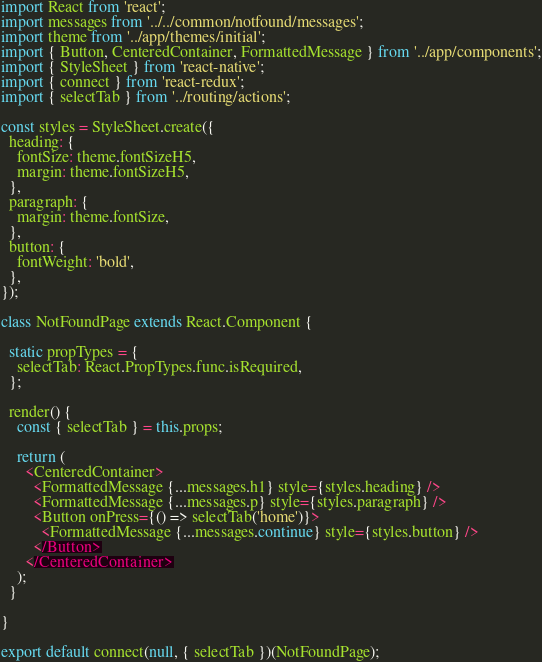Convert code to text. <code><loc_0><loc_0><loc_500><loc_500><_JavaScript_>import React from 'react';
import messages from '../../common/notfound/messages';
import theme from '../app/themes/initial';
import { Button, CenteredContainer, FormattedMessage } from '../app/components';
import { StyleSheet } from 'react-native';
import { connect } from 'react-redux';
import { selectTab } from '../routing/actions';

const styles = StyleSheet.create({
  heading: {
    fontSize: theme.fontSizeH5,
    margin: theme.fontSizeH5,
  },
  paragraph: {
    margin: theme.fontSize,
  },
  button: {
    fontWeight: 'bold',
  },
});

class NotFoundPage extends React.Component {

  static propTypes = {
    selectTab: React.PropTypes.func.isRequired,
  };

  render() {
    const { selectTab } = this.props;

    return (
      <CenteredContainer>
        <FormattedMessage {...messages.h1} style={styles.heading} />
        <FormattedMessage {...messages.p} style={styles.paragraph} />
        <Button onPress={() => selectTab('home')}>
          <FormattedMessage {...messages.continue} style={styles.button} />
        </Button>
      </CenteredContainer>
    );
  }

}

export default connect(null, { selectTab })(NotFoundPage);
</code> 